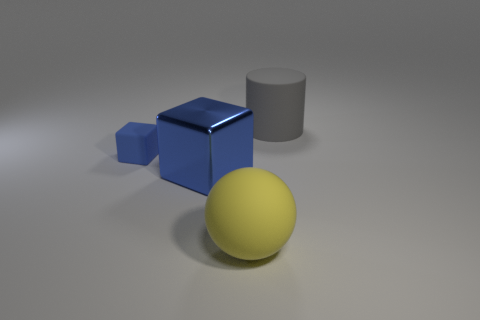How many red objects are either large metal cubes or large rubber cylinders?
Make the answer very short. 0. Are there any things of the same size as the gray matte cylinder?
Keep it short and to the point. Yes. The big thing that is left of the large rubber object in front of the large thing that is behind the big metal cube is made of what material?
Provide a succinct answer. Metal. Are there the same number of blue objects that are in front of the tiny thing and big gray matte things?
Offer a very short reply. Yes. Do the big sphere that is on the right side of the blue matte block and the thing to the right of the yellow matte thing have the same material?
Provide a short and direct response. Yes. What number of things are either tiny cyan matte cubes or things in front of the small thing?
Ensure brevity in your answer.  2. Is there a tiny brown thing of the same shape as the gray matte object?
Keep it short and to the point. No. What is the size of the object that is right of the big matte object that is left of the large matte object that is on the right side of the large yellow matte ball?
Provide a succinct answer. Large. Is the number of large yellow matte objects that are in front of the large blue shiny block the same as the number of large blue objects to the right of the big yellow rubber thing?
Your answer should be very brief. No. What is the size of the blue cube that is the same material as the gray cylinder?
Your response must be concise. Small. 